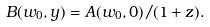<formula> <loc_0><loc_0><loc_500><loc_500>B ( w _ { 0 } , y ) = A ( w _ { 0 } , 0 ) / ( 1 + z ) .</formula> 